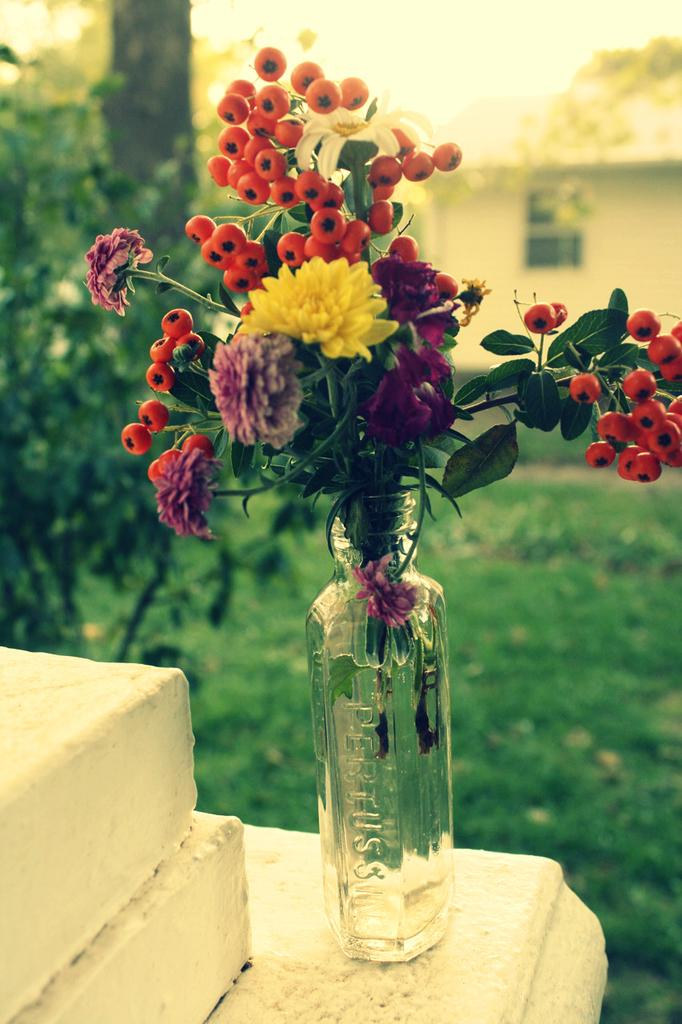What is inside the bottle in the image? There is a flower in a bottle in the image. What can be seen in front of the bottle? There is a garden in front of the bottle. What is visible in the background of the image? There is a home in the background of the image. What type of feeling does the scene in the image evoke? The image does not convey a specific feeling or emotion, as it is a still image of a flower in a bottle, garden, and home. 